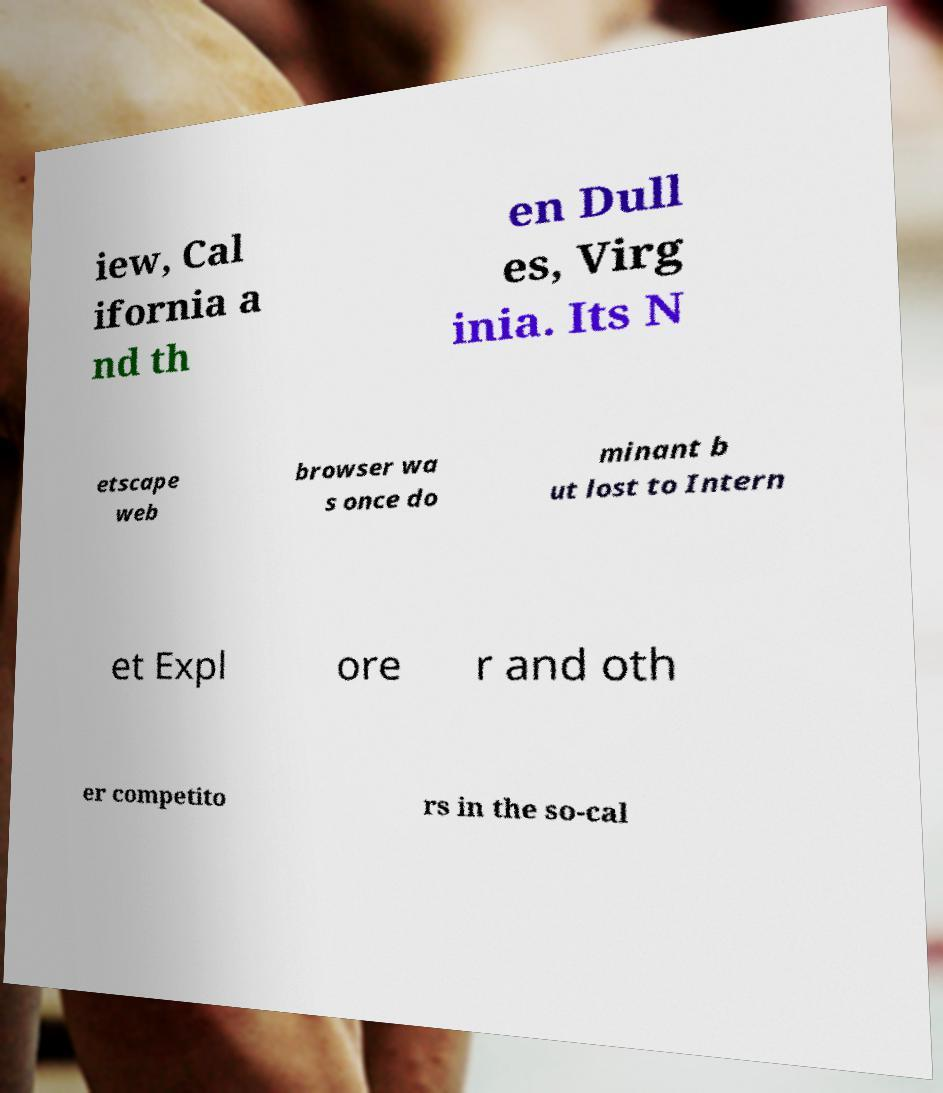Can you accurately transcribe the text from the provided image for me? iew, Cal ifornia a nd th en Dull es, Virg inia. Its N etscape web browser wa s once do minant b ut lost to Intern et Expl ore r and oth er competito rs in the so-cal 